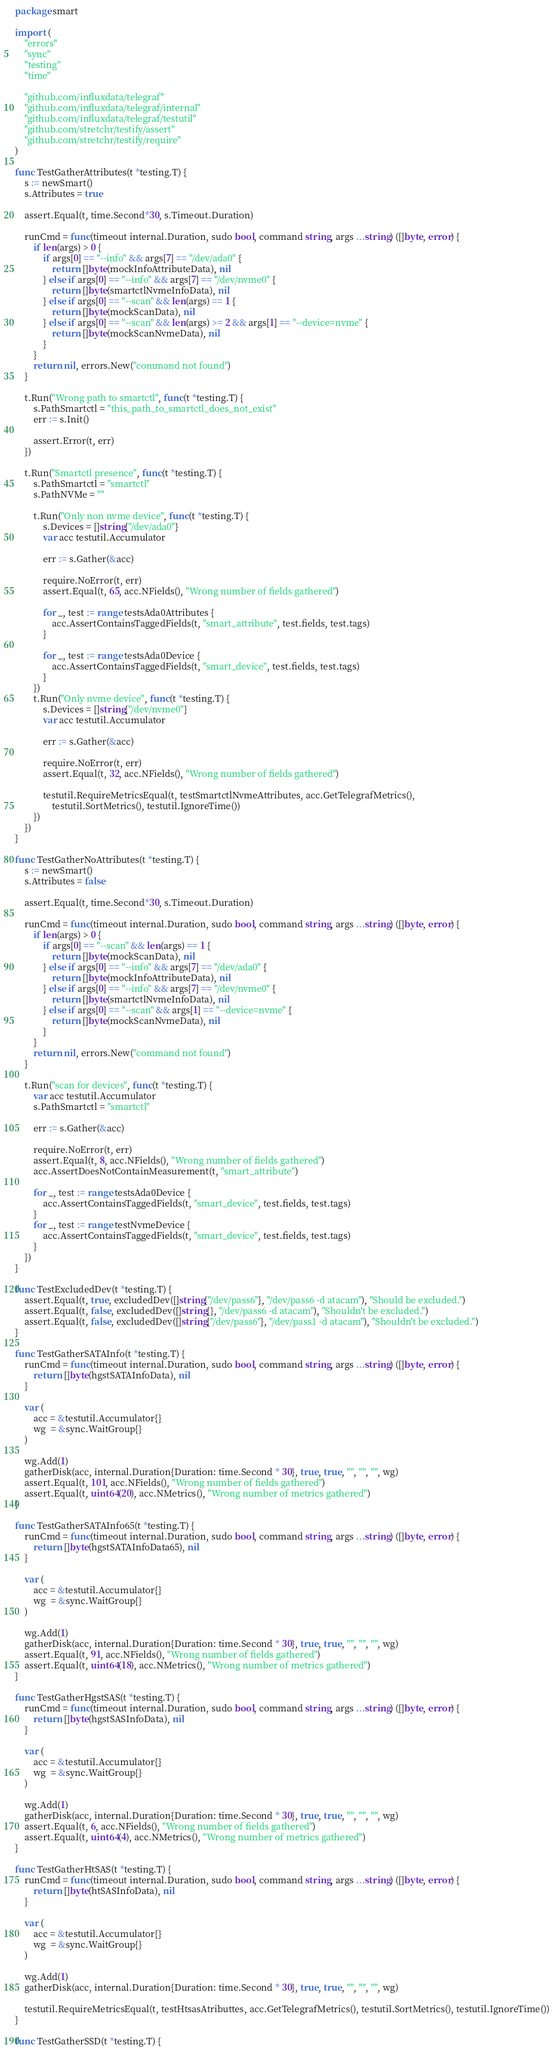Convert code to text. <code><loc_0><loc_0><loc_500><loc_500><_Go_>package smart

import (
	"errors"
	"sync"
	"testing"
	"time"

	"github.com/influxdata/telegraf"
	"github.com/influxdata/telegraf/internal"
	"github.com/influxdata/telegraf/testutil"
	"github.com/stretchr/testify/assert"
	"github.com/stretchr/testify/require"
)

func TestGatherAttributes(t *testing.T) {
	s := newSmart()
	s.Attributes = true

	assert.Equal(t, time.Second*30, s.Timeout.Duration)

	runCmd = func(timeout internal.Duration, sudo bool, command string, args ...string) ([]byte, error) {
		if len(args) > 0 {
			if args[0] == "--info" && args[7] == "/dev/ada0" {
				return []byte(mockInfoAttributeData), nil
			} else if args[0] == "--info" && args[7] == "/dev/nvme0" {
				return []byte(smartctlNvmeInfoData), nil
			} else if args[0] == "--scan" && len(args) == 1 {
				return []byte(mockScanData), nil
			} else if args[0] == "--scan" && len(args) >= 2 && args[1] == "--device=nvme" {
				return []byte(mockScanNvmeData), nil
			}
		}
		return nil, errors.New("command not found")
	}

	t.Run("Wrong path to smartctl", func(t *testing.T) {
		s.PathSmartctl = "this_path_to_smartctl_does_not_exist"
		err := s.Init()

		assert.Error(t, err)
	})

	t.Run("Smartctl presence", func(t *testing.T) {
		s.PathSmartctl = "smartctl"
		s.PathNVMe = ""

		t.Run("Only non nvme device", func(t *testing.T) {
			s.Devices = []string{"/dev/ada0"}
			var acc testutil.Accumulator

			err := s.Gather(&acc)

			require.NoError(t, err)
			assert.Equal(t, 65, acc.NFields(), "Wrong number of fields gathered")

			for _, test := range testsAda0Attributes {
				acc.AssertContainsTaggedFields(t, "smart_attribute", test.fields, test.tags)
			}

			for _, test := range testsAda0Device {
				acc.AssertContainsTaggedFields(t, "smart_device", test.fields, test.tags)
			}
		})
		t.Run("Only nvme device", func(t *testing.T) {
			s.Devices = []string{"/dev/nvme0"}
			var acc testutil.Accumulator

			err := s.Gather(&acc)

			require.NoError(t, err)
			assert.Equal(t, 32, acc.NFields(), "Wrong number of fields gathered")

			testutil.RequireMetricsEqual(t, testSmartctlNvmeAttributes, acc.GetTelegrafMetrics(),
				testutil.SortMetrics(), testutil.IgnoreTime())
		})
	})
}

func TestGatherNoAttributes(t *testing.T) {
	s := newSmart()
	s.Attributes = false

	assert.Equal(t, time.Second*30, s.Timeout.Duration)

	runCmd = func(timeout internal.Duration, sudo bool, command string, args ...string) ([]byte, error) {
		if len(args) > 0 {
			if args[0] == "--scan" && len(args) == 1 {
				return []byte(mockScanData), nil
			} else if args[0] == "--info" && args[7] == "/dev/ada0" {
				return []byte(mockInfoAttributeData), nil
			} else if args[0] == "--info" && args[7] == "/dev/nvme0" {
				return []byte(smartctlNvmeInfoData), nil
			} else if args[0] == "--scan" && args[1] == "--device=nvme" {
				return []byte(mockScanNvmeData), nil
			}
		}
		return nil, errors.New("command not found")
	}

	t.Run("scan for devices", func(t *testing.T) {
		var acc testutil.Accumulator
		s.PathSmartctl = "smartctl"

		err := s.Gather(&acc)

		require.NoError(t, err)
		assert.Equal(t, 8, acc.NFields(), "Wrong number of fields gathered")
		acc.AssertDoesNotContainMeasurement(t, "smart_attribute")

		for _, test := range testsAda0Device {
			acc.AssertContainsTaggedFields(t, "smart_device", test.fields, test.tags)
		}
		for _, test := range testNvmeDevice {
			acc.AssertContainsTaggedFields(t, "smart_device", test.fields, test.tags)
		}
	})
}

func TestExcludedDev(t *testing.T) {
	assert.Equal(t, true, excludedDev([]string{"/dev/pass6"}, "/dev/pass6 -d atacam"), "Should be excluded.")
	assert.Equal(t, false, excludedDev([]string{}, "/dev/pass6 -d atacam"), "Shouldn't be excluded.")
	assert.Equal(t, false, excludedDev([]string{"/dev/pass6"}, "/dev/pass1 -d atacam"), "Shouldn't be excluded.")
}

func TestGatherSATAInfo(t *testing.T) {
	runCmd = func(timeout internal.Duration, sudo bool, command string, args ...string) ([]byte, error) {
		return []byte(hgstSATAInfoData), nil
	}

	var (
		acc = &testutil.Accumulator{}
		wg  = &sync.WaitGroup{}
	)

	wg.Add(1)
	gatherDisk(acc, internal.Duration{Duration: time.Second * 30}, true, true, "", "", "", wg)
	assert.Equal(t, 101, acc.NFields(), "Wrong number of fields gathered")
	assert.Equal(t, uint64(20), acc.NMetrics(), "Wrong number of metrics gathered")
}

func TestGatherSATAInfo65(t *testing.T) {
	runCmd = func(timeout internal.Duration, sudo bool, command string, args ...string) ([]byte, error) {
		return []byte(hgstSATAInfoData65), nil
	}

	var (
		acc = &testutil.Accumulator{}
		wg  = &sync.WaitGroup{}
	)

	wg.Add(1)
	gatherDisk(acc, internal.Duration{Duration: time.Second * 30}, true, true, "", "", "", wg)
	assert.Equal(t, 91, acc.NFields(), "Wrong number of fields gathered")
	assert.Equal(t, uint64(18), acc.NMetrics(), "Wrong number of metrics gathered")
}

func TestGatherHgstSAS(t *testing.T) {
	runCmd = func(timeout internal.Duration, sudo bool, command string, args ...string) ([]byte, error) {
		return []byte(hgstSASInfoData), nil
	}

	var (
		acc = &testutil.Accumulator{}
		wg  = &sync.WaitGroup{}
	)

	wg.Add(1)
	gatherDisk(acc, internal.Duration{Duration: time.Second * 30}, true, true, "", "", "", wg)
	assert.Equal(t, 6, acc.NFields(), "Wrong number of fields gathered")
	assert.Equal(t, uint64(4), acc.NMetrics(), "Wrong number of metrics gathered")
}

func TestGatherHtSAS(t *testing.T) {
	runCmd = func(timeout internal.Duration, sudo bool, command string, args ...string) ([]byte, error) {
		return []byte(htSASInfoData), nil
	}

	var (
		acc = &testutil.Accumulator{}
		wg  = &sync.WaitGroup{}
	)

	wg.Add(1)
	gatherDisk(acc, internal.Duration{Duration: time.Second * 30}, true, true, "", "", "", wg)

	testutil.RequireMetricsEqual(t, testHtsasAtributtes, acc.GetTelegrafMetrics(), testutil.SortMetrics(), testutil.IgnoreTime())
}

func TestGatherSSD(t *testing.T) {</code> 